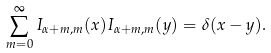<formula> <loc_0><loc_0><loc_500><loc_500>\sum _ { m = 0 } ^ { \infty } I _ { \alpha + m , m } ( x ) I _ { \alpha + m , m } ( y ) = \delta ( x - y ) .</formula> 